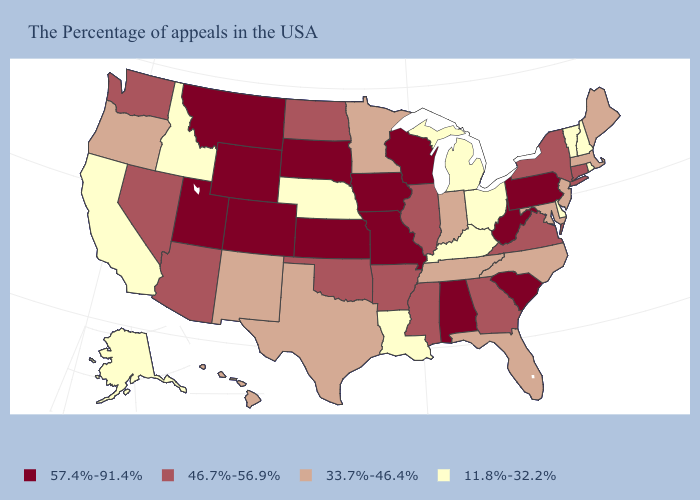Is the legend a continuous bar?
Be succinct. No. What is the value of Illinois?
Write a very short answer. 46.7%-56.9%. What is the value of North Carolina?
Keep it brief. 33.7%-46.4%. What is the value of Missouri?
Keep it brief. 57.4%-91.4%. Name the states that have a value in the range 33.7%-46.4%?
Keep it brief. Maine, Massachusetts, New Jersey, Maryland, North Carolina, Florida, Indiana, Tennessee, Minnesota, Texas, New Mexico, Oregon, Hawaii. What is the value of Idaho?
Answer briefly. 11.8%-32.2%. Does the map have missing data?
Quick response, please. No. Among the states that border Massachusetts , does Rhode Island have the highest value?
Keep it brief. No. What is the value of North Dakota?
Quick response, please. 46.7%-56.9%. Does Pennsylvania have a higher value than Utah?
Concise answer only. No. What is the highest value in states that border New Hampshire?
Give a very brief answer. 33.7%-46.4%. Does Colorado have the same value as Missouri?
Concise answer only. Yes. Name the states that have a value in the range 46.7%-56.9%?
Write a very short answer. Connecticut, New York, Virginia, Georgia, Illinois, Mississippi, Arkansas, Oklahoma, North Dakota, Arizona, Nevada, Washington. What is the lowest value in the USA?
Concise answer only. 11.8%-32.2%. 